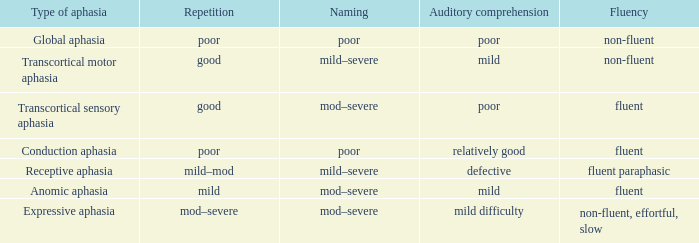Name the naming for fluent and poor comprehension Mod–severe. 